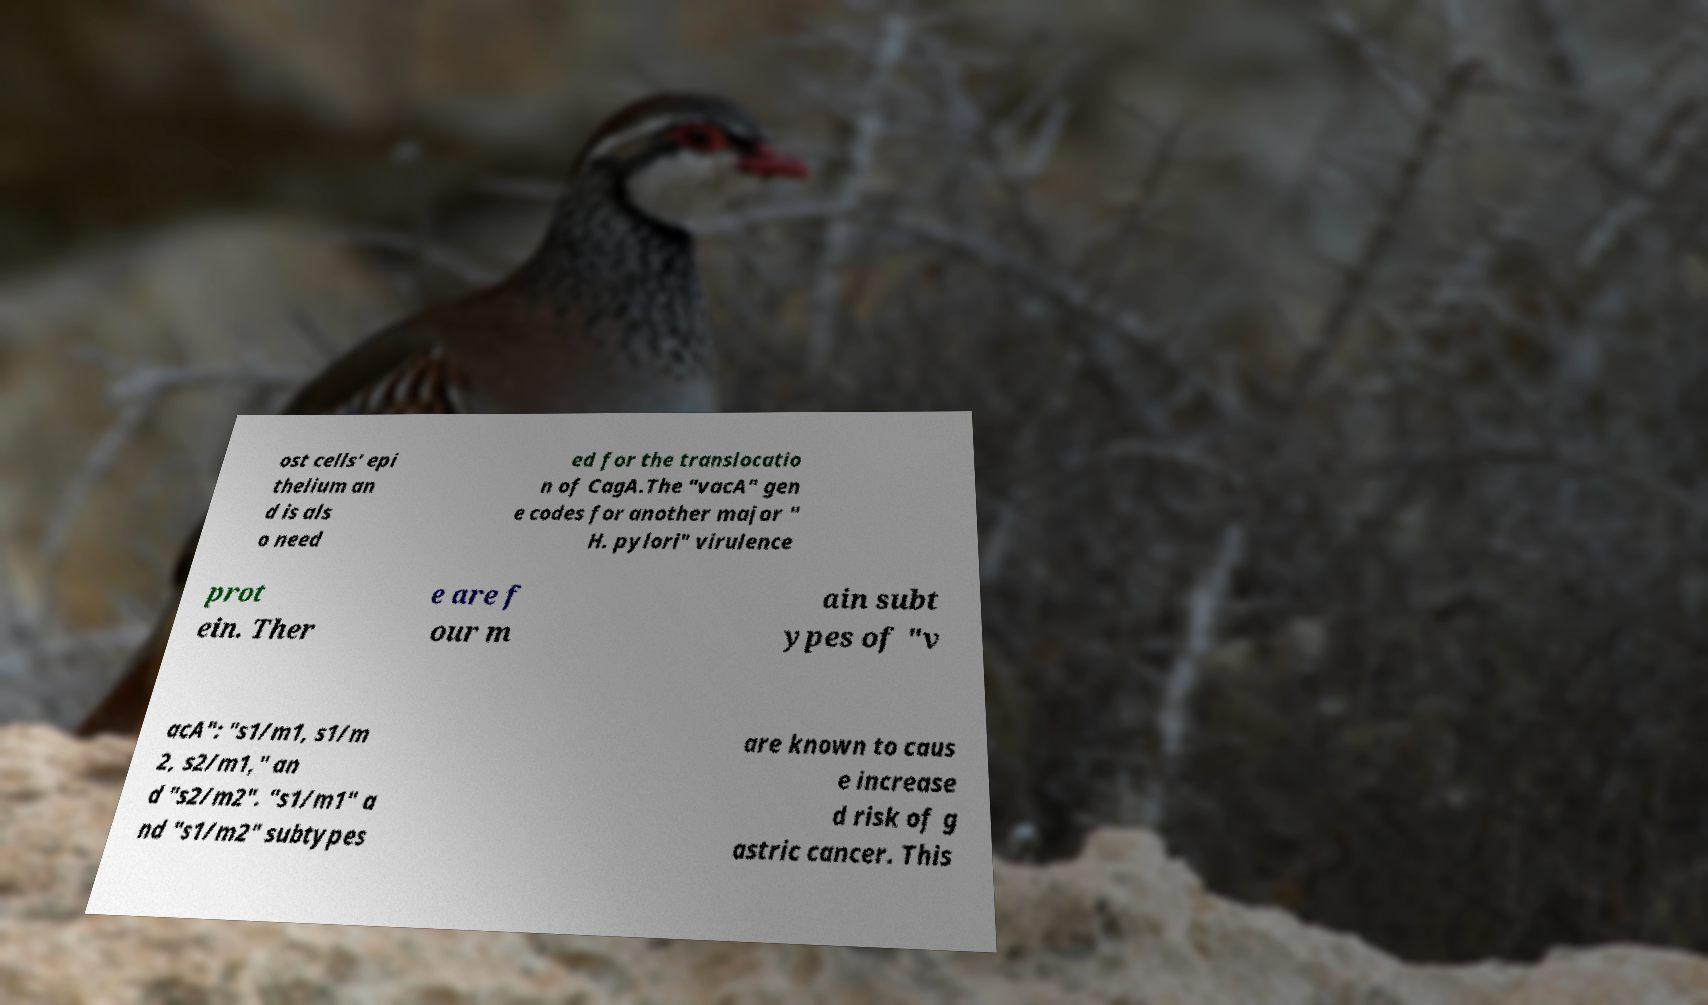Please read and relay the text visible in this image. What does it say? ost cells' epi thelium an d is als o need ed for the translocatio n of CagA.The "vacA" gen e codes for another major " H. pylori" virulence prot ein. Ther e are f our m ain subt ypes of "v acA": "s1/m1, s1/m 2, s2/m1," an d "s2/m2". "s1/m1" a nd "s1/m2" subtypes are known to caus e increase d risk of g astric cancer. This 